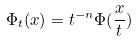Convert formula to latex. <formula><loc_0><loc_0><loc_500><loc_500>\Phi _ { t } ( x ) = t ^ { - n } \Phi ( \frac { x } { t } )</formula> 